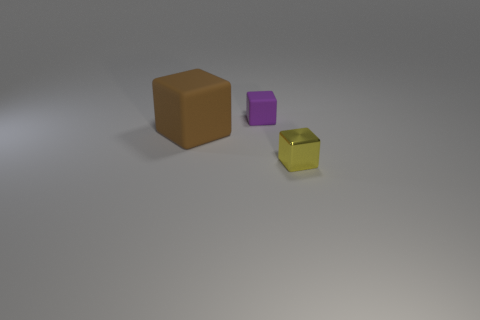What is the size of the other yellow thing that is the same shape as the large matte object?
Offer a terse response. Small. What material is the big cube?
Your answer should be very brief. Rubber. How many brown objects have the same size as the metallic block?
Provide a succinct answer. 0. Are there any other large purple rubber objects that have the same shape as the big matte thing?
Make the answer very short. No. The cube that is the same size as the purple rubber object is what color?
Provide a succinct answer. Yellow. The small block that is on the left side of the cube that is in front of the big matte thing is what color?
Provide a succinct answer. Purple. Do the small object that is on the left side of the tiny metallic block and the large matte cube have the same color?
Keep it short and to the point. No. There is a small object that is right of the tiny thing left of the small object that is in front of the purple cube; what is its shape?
Make the answer very short. Cube. What number of small things are in front of the small block behind the tiny yellow metal cube?
Provide a succinct answer. 1. Are the purple thing and the large brown thing made of the same material?
Provide a succinct answer. Yes. 